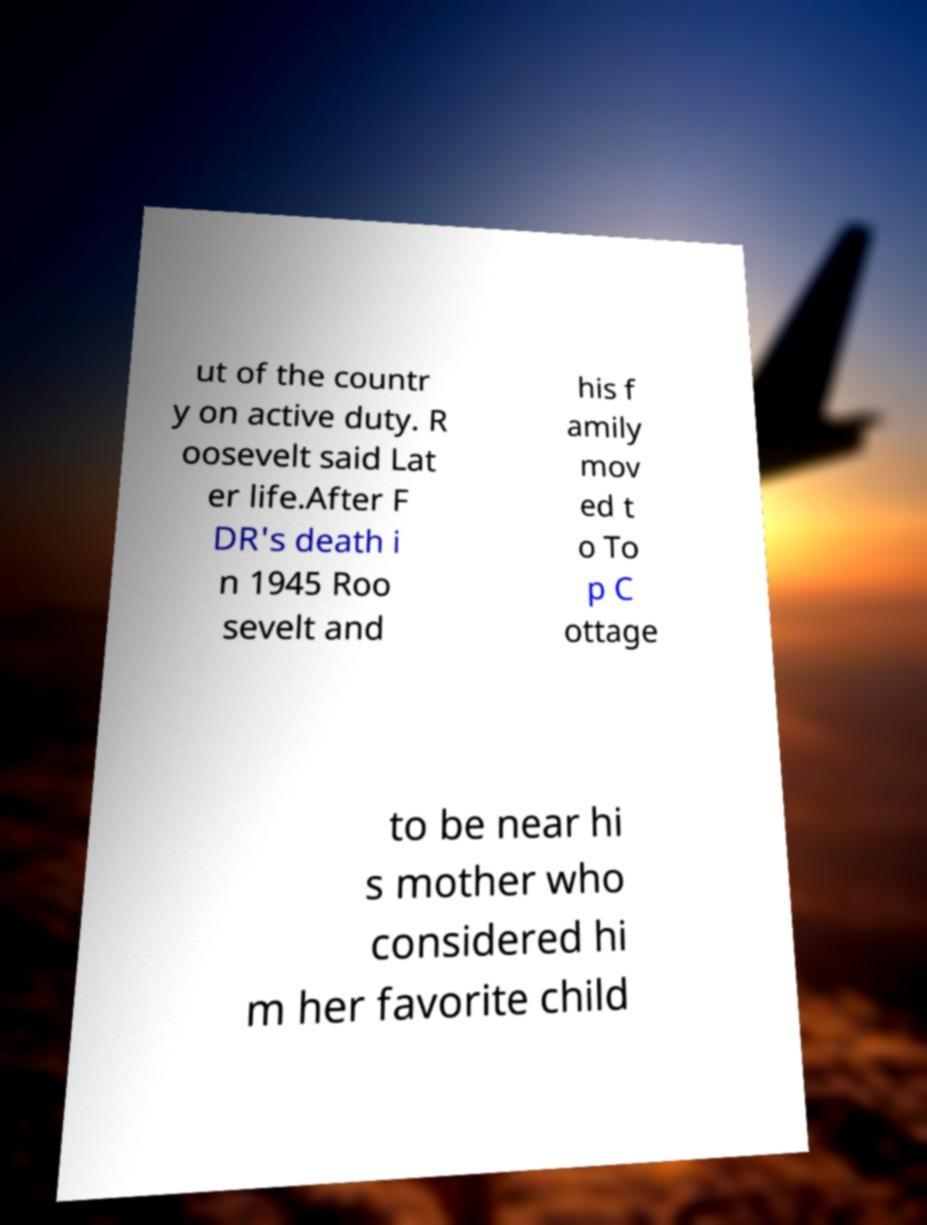Could you assist in decoding the text presented in this image and type it out clearly? ut of the countr y on active duty. R oosevelt said Lat er life.After F DR's death i n 1945 Roo sevelt and his f amily mov ed t o To p C ottage to be near hi s mother who considered hi m her favorite child 